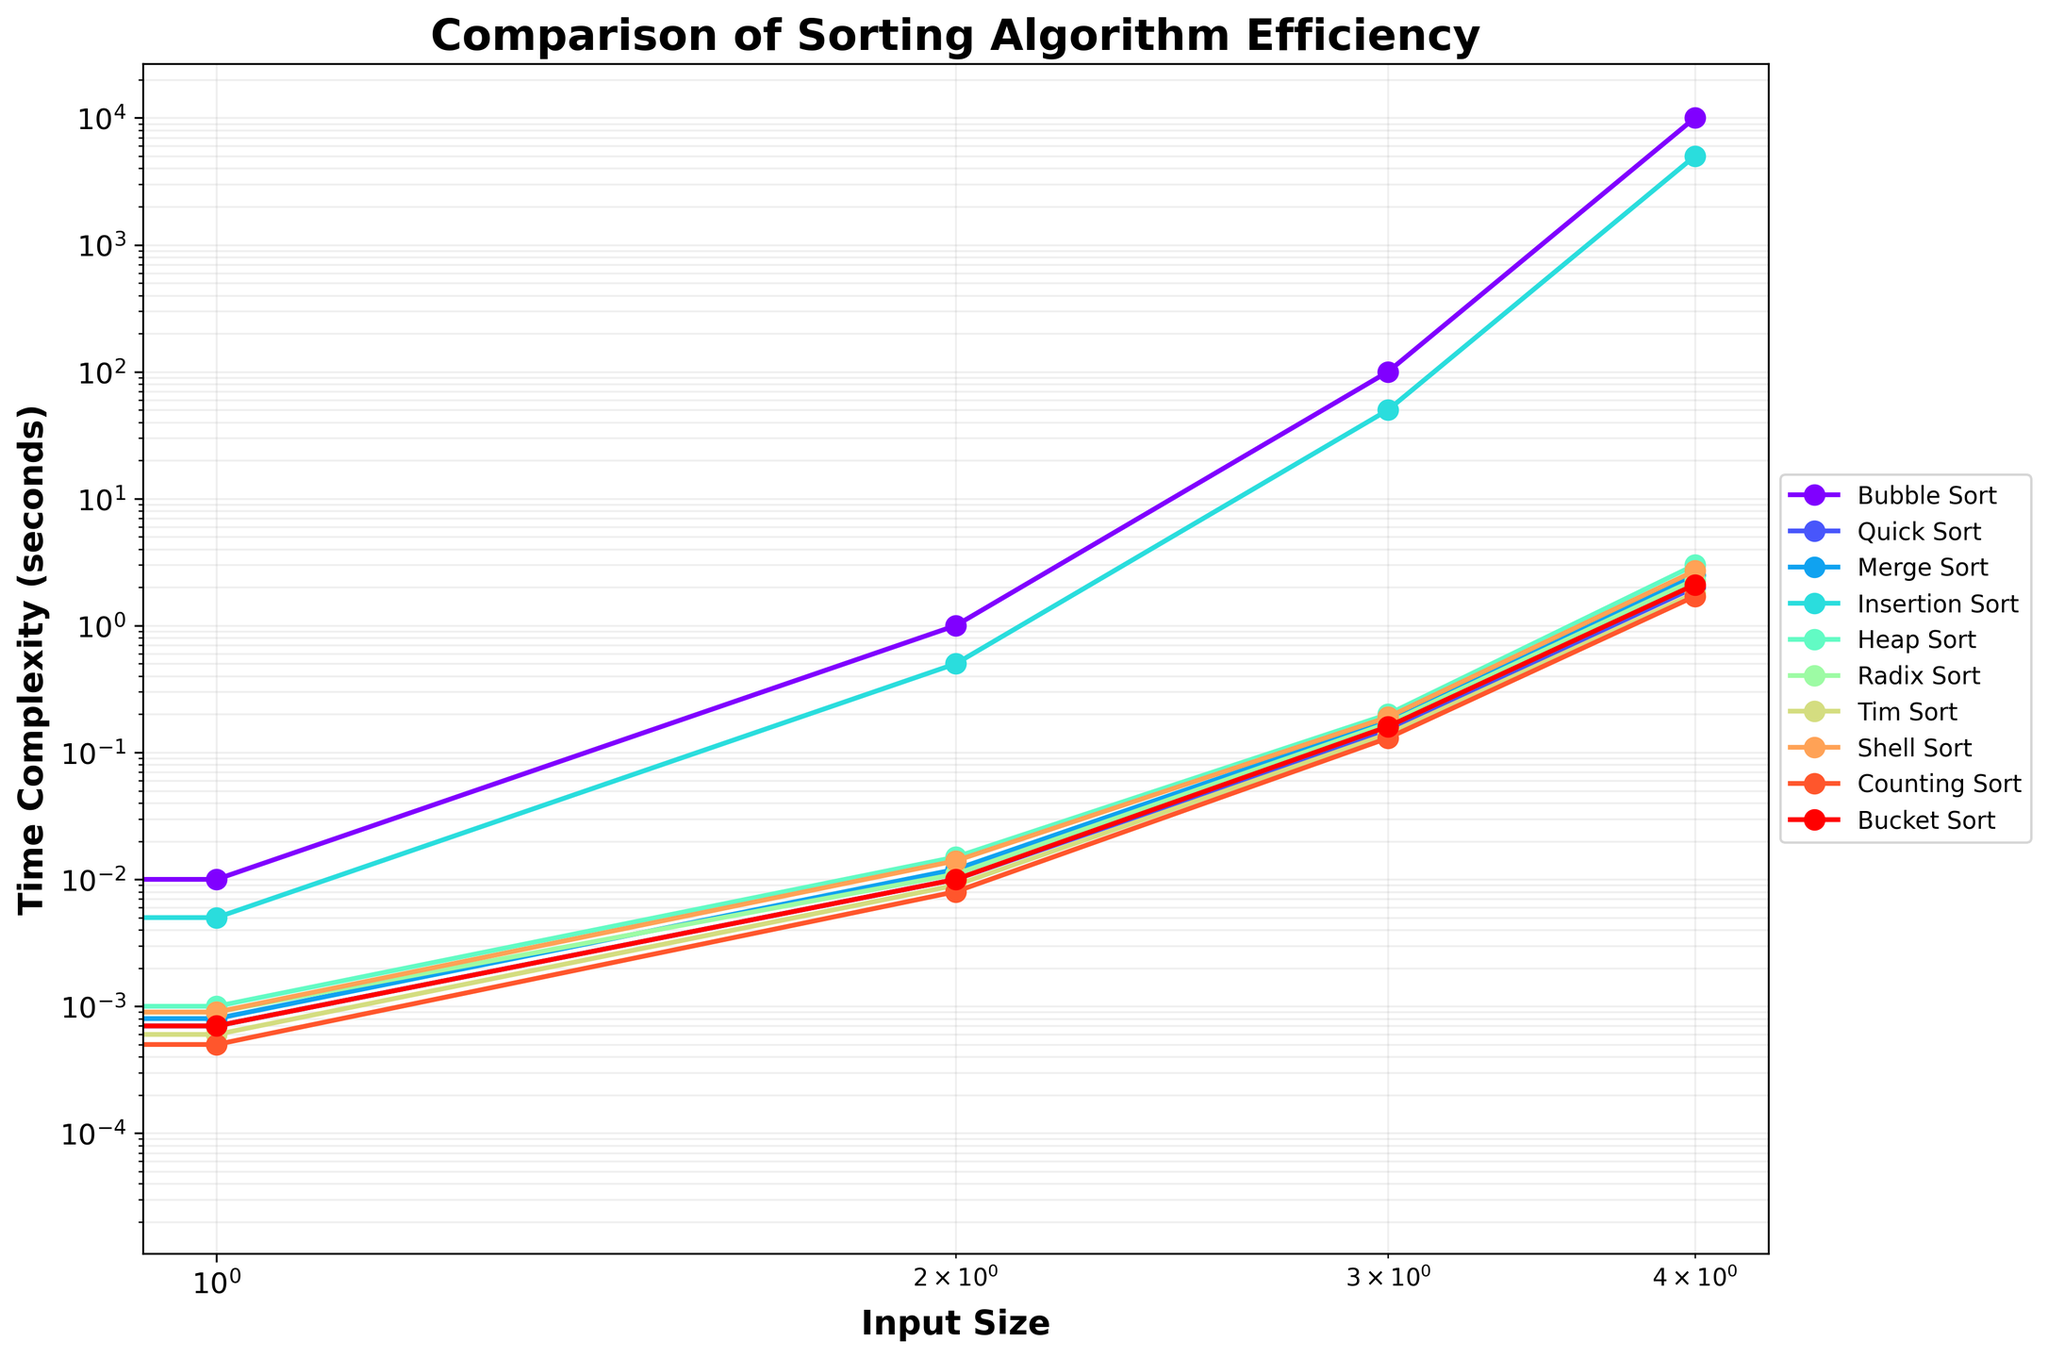What algorithm shows the best performance for 100000 elements? First, locate the '100000 elements' column. Then, visually inspect which algorithm has the lowest time complexity (value).
Answer: Counting Sort Which algorithms have an approximately linear time complexity based on the chart? In the chart, algorithms with linear time complexity will appear as straight lines with a positive slope in the logarithmic scale. Identify these lines.
Answer: Quick Sort, Merge Sort, Radix Sort, Tim Sort, Counting Sort, Bucket Sort How much faster is Quick Sort compared to Bubble Sort for 1000 elements? Find the values for Quick Sort and Bubble Sort at '1000 elements'. Calculate the difference by subtracting Quick Sort's value from Bubble Sort's value.
Answer: 0.99 seconds Which algorithm exhibits the steepest increase in time complexity as the input size increases? Analyze the slope of each line in the chart. The steeper the line, the faster the time complexity increases.
Answer: Bubble Sort Is the performance of Merge Sort similar to any other algorithm at all input sizes? Compare the line representing Merge Sort to other lines. Check if any other line closely follows the same curve at all input sizes.
Answer: Quick Sort What's the combined time complexity of Radix Sort and Heap Sort for 10000 elements? Find the values for Radix Sort and Heap Sort at '10000 elements'. Add these two values together.
Answer: 0.37 seconds Identify the algorithm that is consistently faster than Shell Sort but slower than one other algorithm for all input sizes. Compare each line by visually inspecting their positions relative to the Shell Sort line across all input sizes.
Answer: Tim Sort How does the performance of Insertion Sort compare to Bubble Sort for 100 elements? Check the values for Insertion Sort and Bubble Sort at '100 elements'. Compare these two values to determine which one is larger.
Answer: Insertion Sort is faster 